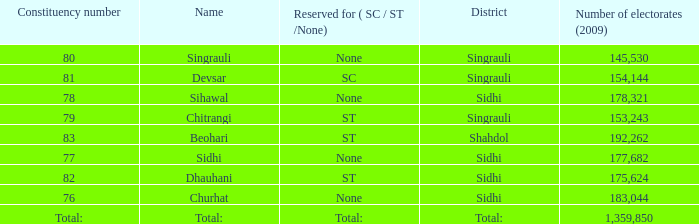What is the district with 79 constituency number? Singrauli. 